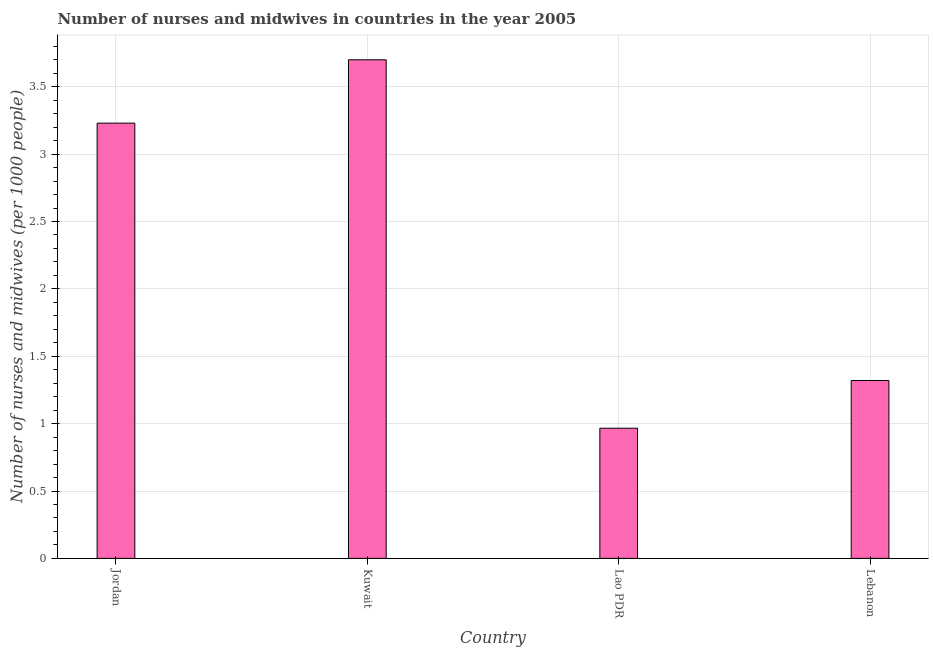What is the title of the graph?
Your answer should be very brief. Number of nurses and midwives in countries in the year 2005. What is the label or title of the Y-axis?
Offer a very short reply. Number of nurses and midwives (per 1000 people). What is the number of nurses and midwives in Jordan?
Keep it short and to the point. 3.23. Across all countries, what is the maximum number of nurses and midwives?
Your response must be concise. 3.7. Across all countries, what is the minimum number of nurses and midwives?
Make the answer very short. 0.97. In which country was the number of nurses and midwives maximum?
Make the answer very short. Kuwait. In which country was the number of nurses and midwives minimum?
Your response must be concise. Lao PDR. What is the sum of the number of nurses and midwives?
Give a very brief answer. 9.22. What is the difference between the number of nurses and midwives in Jordan and Lebanon?
Your answer should be compact. 1.91. What is the average number of nurses and midwives per country?
Your response must be concise. 2.3. What is the median number of nurses and midwives?
Your response must be concise. 2.27. In how many countries, is the number of nurses and midwives greater than 0.7 ?
Your response must be concise. 4. What is the ratio of the number of nurses and midwives in Lao PDR to that in Lebanon?
Provide a short and direct response. 0.73. Is the number of nurses and midwives in Jordan less than that in Kuwait?
Make the answer very short. Yes. What is the difference between the highest and the second highest number of nurses and midwives?
Offer a very short reply. 0.47. What is the difference between the highest and the lowest number of nurses and midwives?
Offer a very short reply. 2.73. In how many countries, is the number of nurses and midwives greater than the average number of nurses and midwives taken over all countries?
Make the answer very short. 2. Are all the bars in the graph horizontal?
Provide a short and direct response. No. How many countries are there in the graph?
Ensure brevity in your answer.  4. What is the difference between two consecutive major ticks on the Y-axis?
Ensure brevity in your answer.  0.5. What is the Number of nurses and midwives (per 1000 people) in Jordan?
Your response must be concise. 3.23. What is the Number of nurses and midwives (per 1000 people) in Lebanon?
Your answer should be compact. 1.32. What is the difference between the Number of nurses and midwives (per 1000 people) in Jordan and Kuwait?
Offer a very short reply. -0.47. What is the difference between the Number of nurses and midwives (per 1000 people) in Jordan and Lao PDR?
Make the answer very short. 2.26. What is the difference between the Number of nurses and midwives (per 1000 people) in Jordan and Lebanon?
Your answer should be compact. 1.91. What is the difference between the Number of nurses and midwives (per 1000 people) in Kuwait and Lao PDR?
Make the answer very short. 2.73. What is the difference between the Number of nurses and midwives (per 1000 people) in Kuwait and Lebanon?
Give a very brief answer. 2.38. What is the difference between the Number of nurses and midwives (per 1000 people) in Lao PDR and Lebanon?
Keep it short and to the point. -0.35. What is the ratio of the Number of nurses and midwives (per 1000 people) in Jordan to that in Kuwait?
Offer a terse response. 0.87. What is the ratio of the Number of nurses and midwives (per 1000 people) in Jordan to that in Lao PDR?
Ensure brevity in your answer.  3.34. What is the ratio of the Number of nurses and midwives (per 1000 people) in Jordan to that in Lebanon?
Offer a terse response. 2.45. What is the ratio of the Number of nurses and midwives (per 1000 people) in Kuwait to that in Lao PDR?
Offer a terse response. 3.83. What is the ratio of the Number of nurses and midwives (per 1000 people) in Kuwait to that in Lebanon?
Offer a terse response. 2.8. What is the ratio of the Number of nurses and midwives (per 1000 people) in Lao PDR to that in Lebanon?
Offer a very short reply. 0.73. 